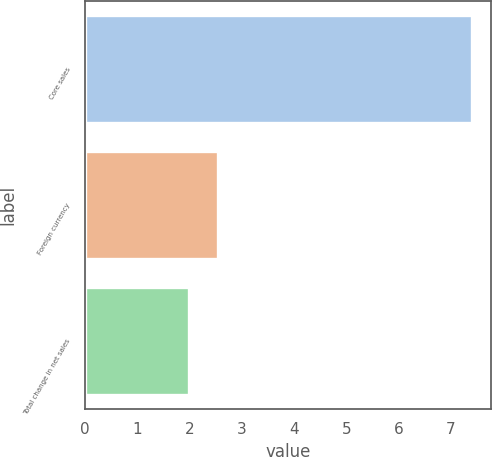<chart> <loc_0><loc_0><loc_500><loc_500><bar_chart><fcel>Core sales<fcel>Foreign currency<fcel>Total change in net sales<nl><fcel>7.4<fcel>2.54<fcel>2<nl></chart> 